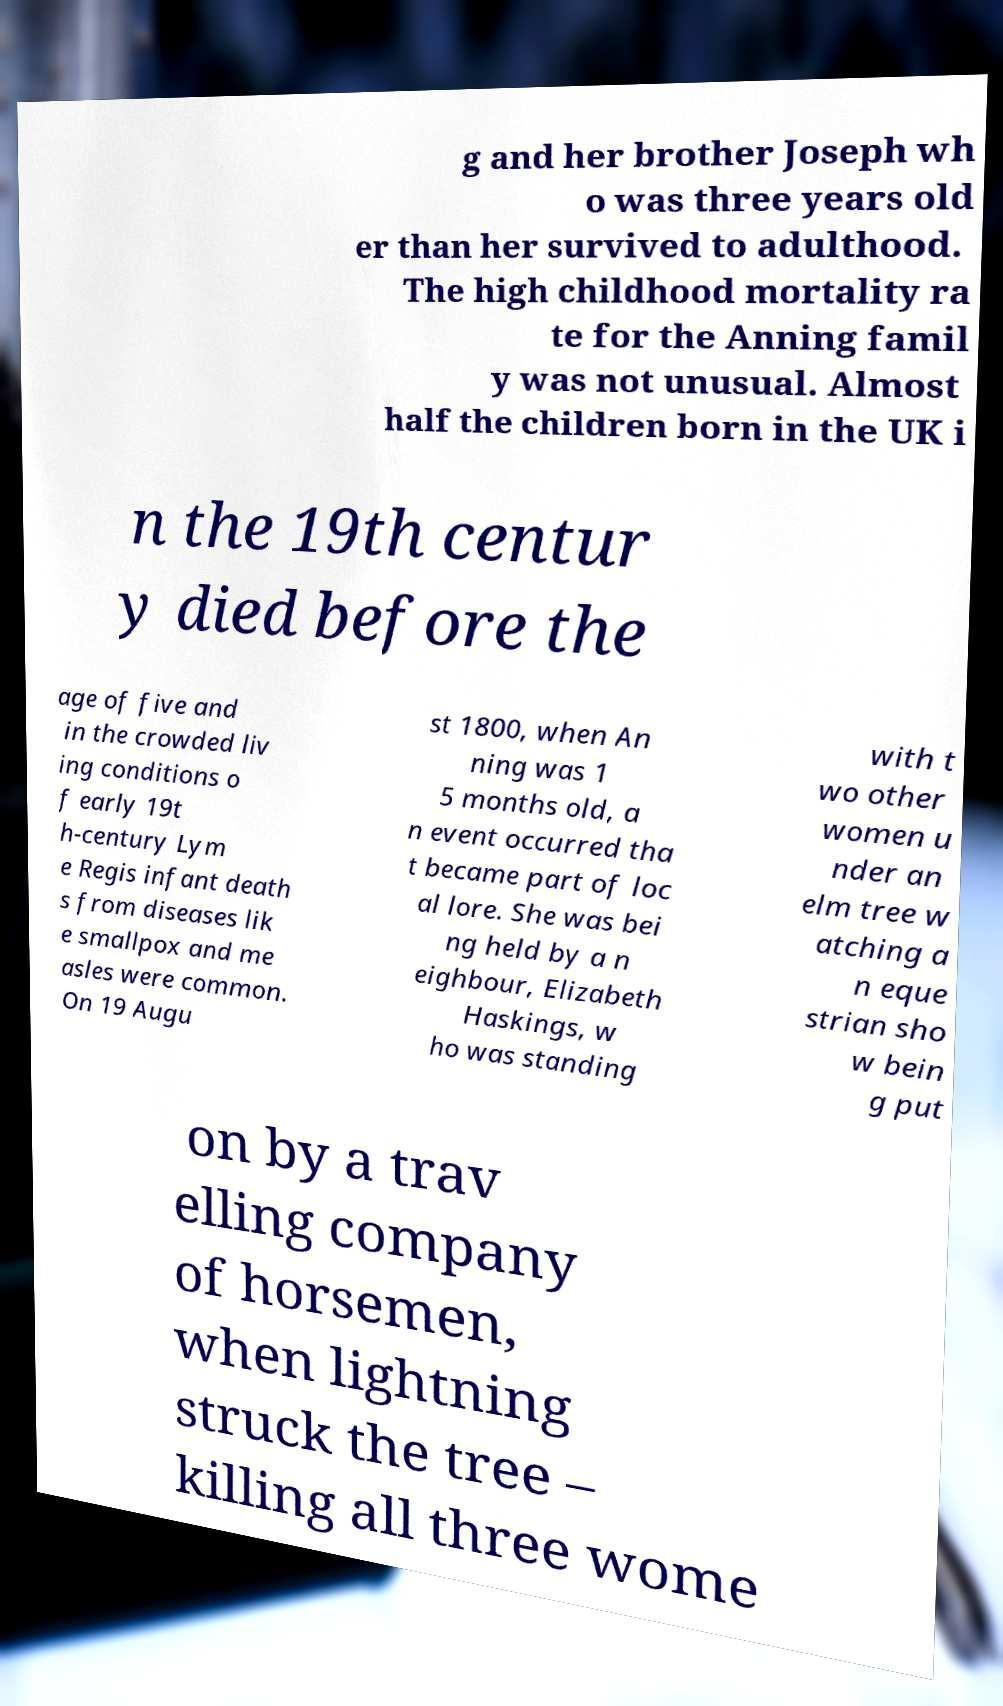Can you accurately transcribe the text from the provided image for me? g and her brother Joseph wh o was three years old er than her survived to adulthood. The high childhood mortality ra te for the Anning famil y was not unusual. Almost half the children born in the UK i n the 19th centur y died before the age of five and in the crowded liv ing conditions o f early 19t h-century Lym e Regis infant death s from diseases lik e smallpox and me asles were common. On 19 Augu st 1800, when An ning was 1 5 months old, a n event occurred tha t became part of loc al lore. She was bei ng held by a n eighbour, Elizabeth Haskings, w ho was standing with t wo other women u nder an elm tree w atching a n eque strian sho w bein g put on by a trav elling company of horsemen, when lightning struck the tree – killing all three wome 